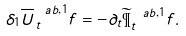Convert formula to latex. <formula><loc_0><loc_0><loc_500><loc_500>\delta _ { 1 } \overline { U } ^ { \ a b , 1 } _ { \, t } f = - \partial _ { t } \widetilde { \P } ^ { \ a b , 1 } _ { t } f .</formula> 